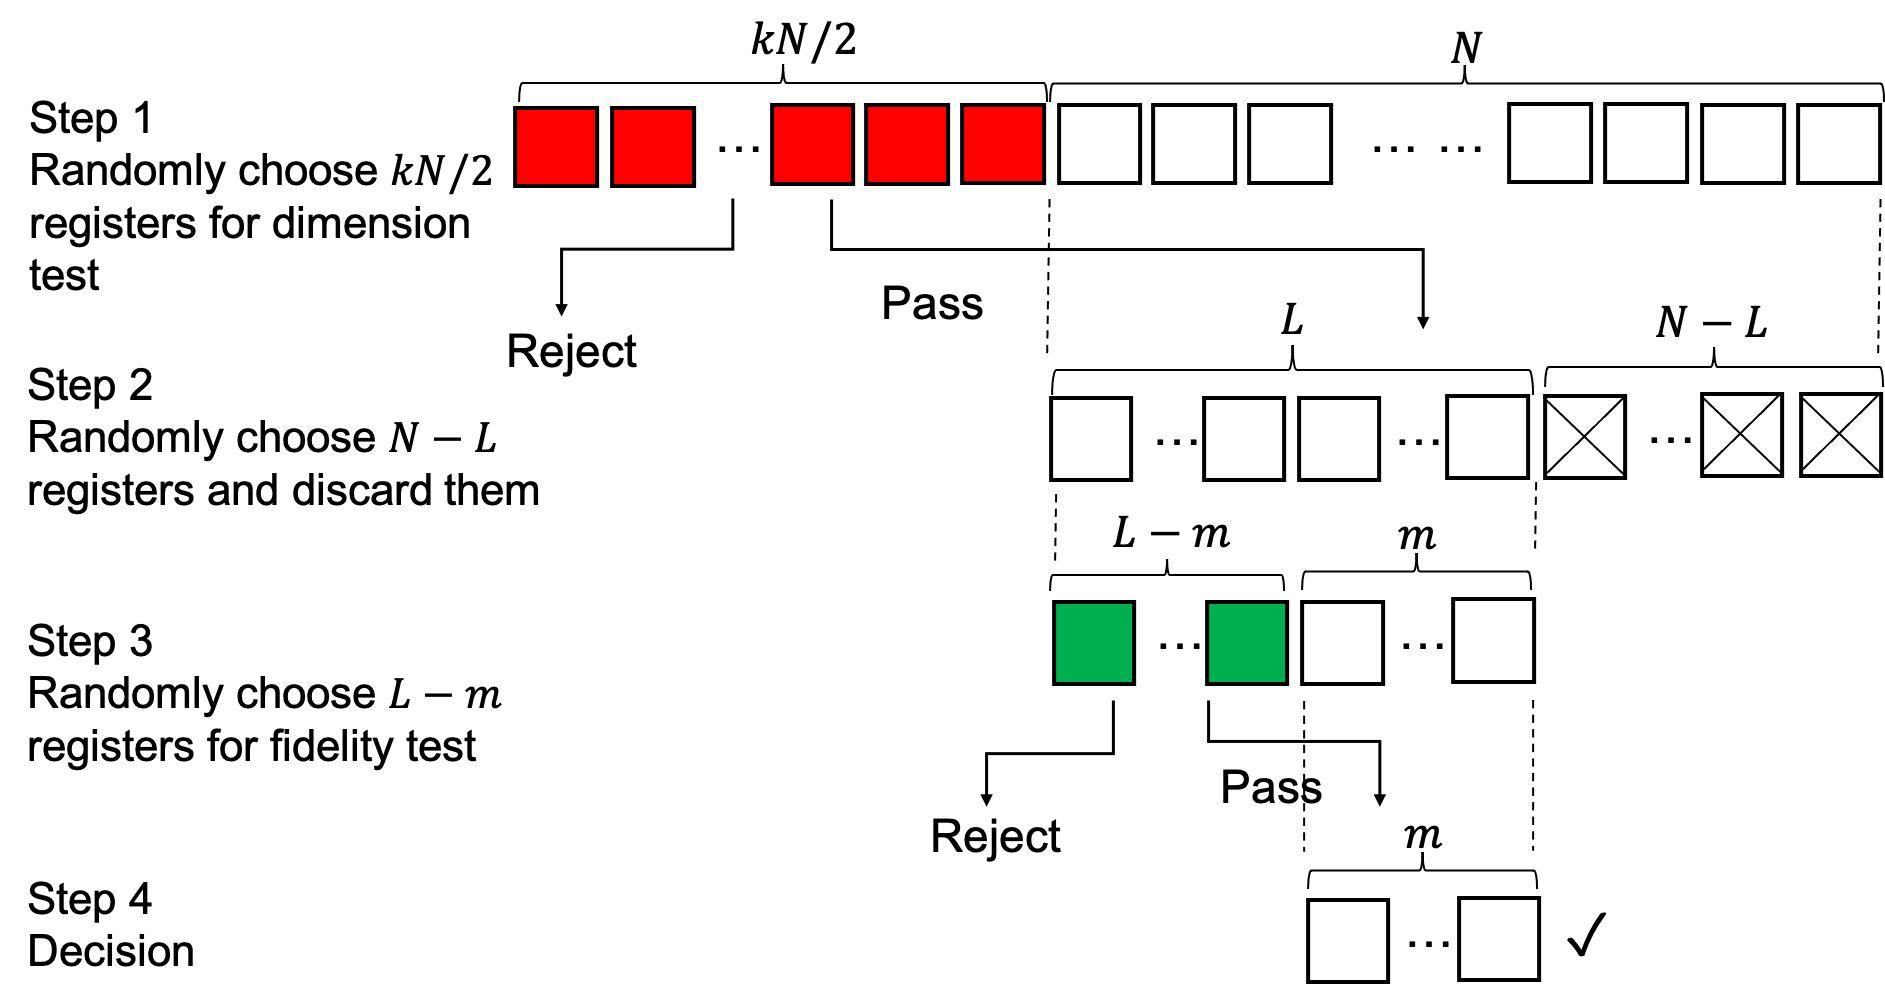Could you explain the purpose of Step 2 and why some registers are discarded? Certainly! Step 2 in the figure acts as a further filtering mechanism that randomly selects a subset of registers to advance. Specifically, it chooses N - L registers to continue, while L registers are discarded. This step seems to serve the purpose of narrowing down the group of registers based on quantity, quite possibly to manage the scope of the following fidelity test in Step 3. By reducing the number of registers, the process can more efficiently focus on those more likely to meet the final requirements. 